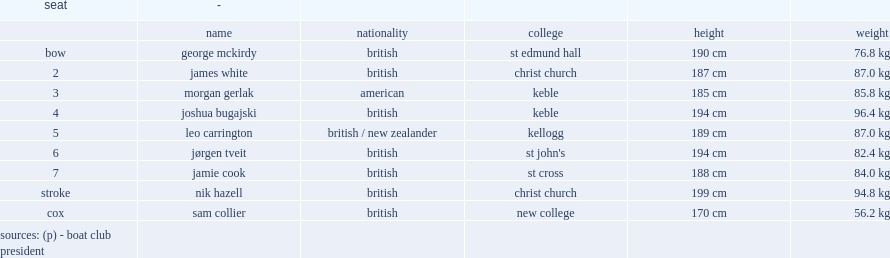What was the weight of joshua bugajski? 96.4 kg. 